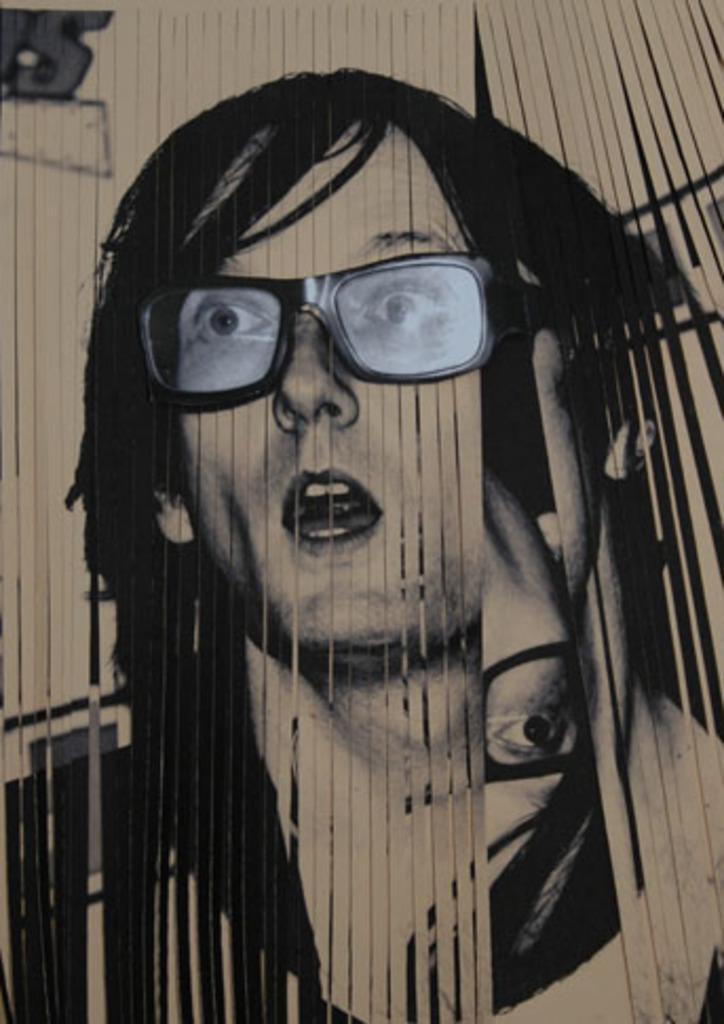Please provide a concise description of this image. In this picture there is a white color object seems to be the vertical window blind and we can see the pictures of persons on the window blinds. 